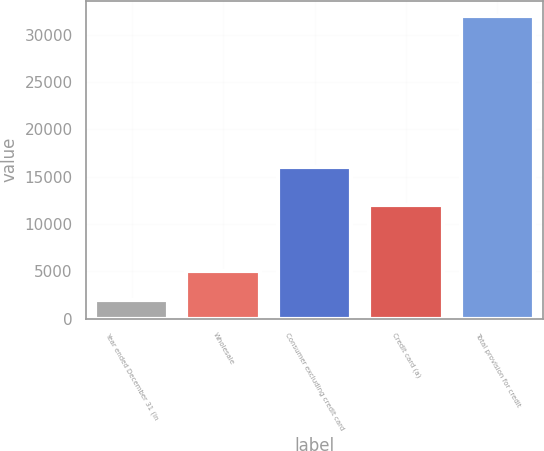Convert chart. <chart><loc_0><loc_0><loc_500><loc_500><bar_chart><fcel>Year ended December 31 (in<fcel>Wholesale<fcel>Consumer excluding credit card<fcel>Credit card (a)<fcel>Total provision for credit<nl><fcel>2009<fcel>5009.6<fcel>16022<fcel>12019<fcel>32015<nl></chart> 